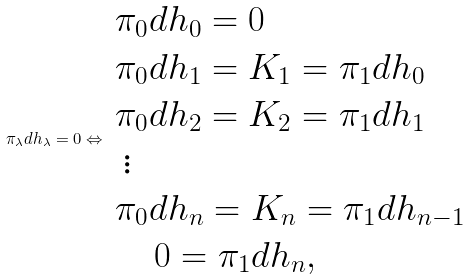<formula> <loc_0><loc_0><loc_500><loc_500>\pi _ { \lambda } d h _ { \lambda } = 0 \Leftrightarrow \begin{array} { l } \pi _ { 0 } d h _ { 0 } = 0 \\ \pi _ { 0 } d h _ { 1 } = K _ { 1 } = \pi _ { 1 } d h _ { 0 } \\ \pi _ { 0 } d h _ { 2 } = K _ { 2 } = \pi _ { 1 } d h _ { 1 } \\ \, \vdots \\ \pi _ { 0 } d h _ { n } = K _ { n } = \pi _ { 1 } d h _ { n - 1 } \\ \quad \, 0 = \pi _ { 1 } d h _ { n } , \, \end{array}</formula> 